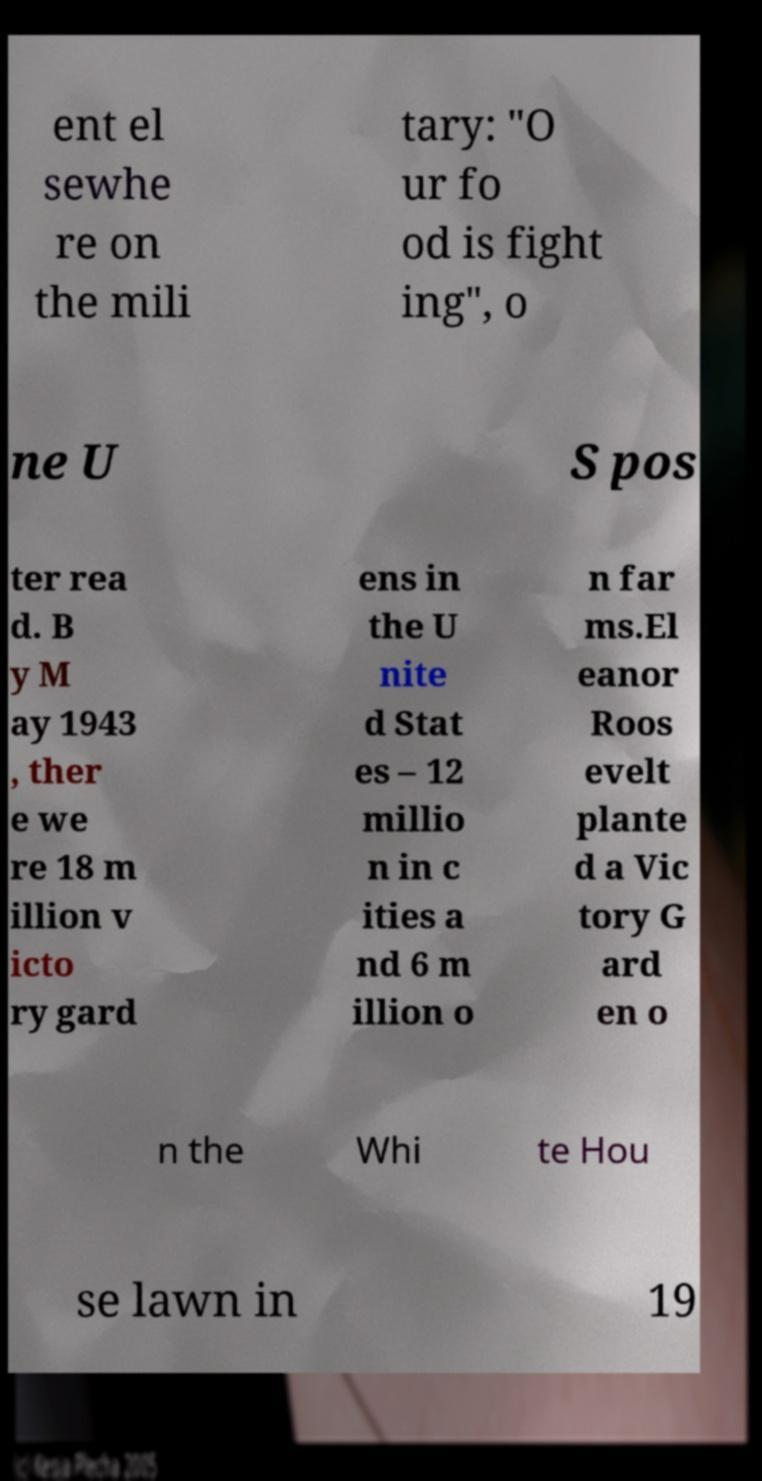Please identify and transcribe the text found in this image. ent el sewhe re on the mili tary: "O ur fo od is fight ing", o ne U S pos ter rea d. B y M ay 1943 , ther e we re 18 m illion v icto ry gard ens in the U nite d Stat es – 12 millio n in c ities a nd 6 m illion o n far ms.El eanor Roos evelt plante d a Vic tory G ard en o n the Whi te Hou se lawn in 19 